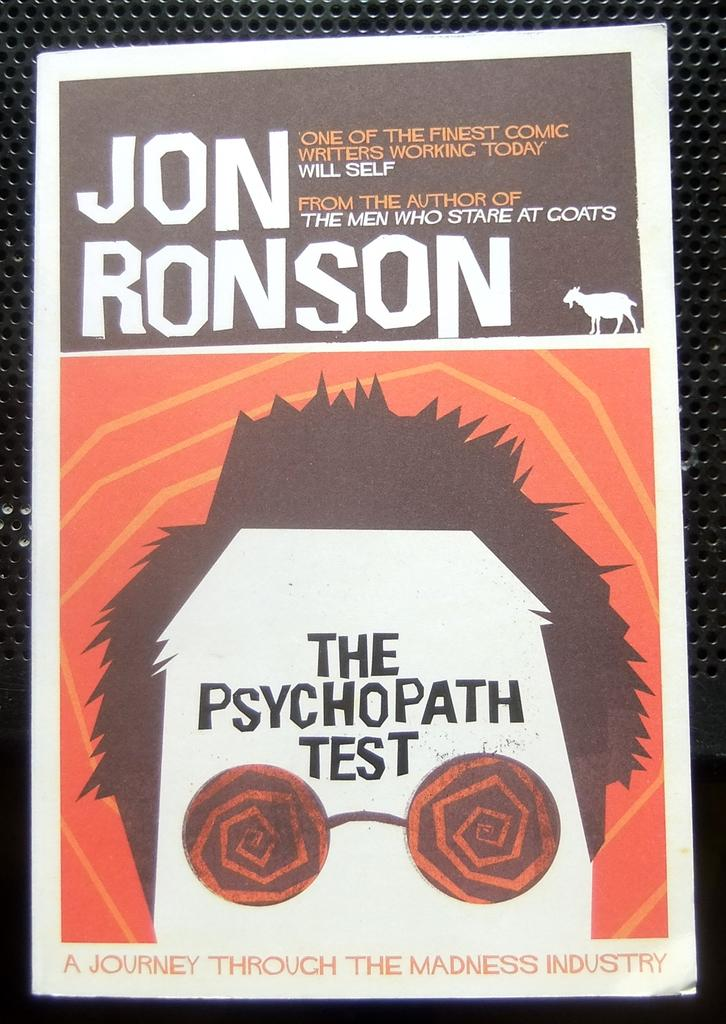<image>
Provide a brief description of the given image. A poster advertising Jon Ronson's new work "The Psychopath Test" has an orange background. 